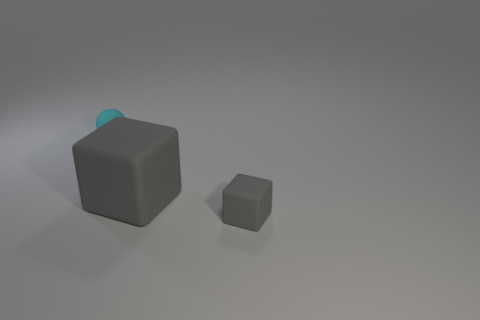What is the color of the block that is made of the same material as the large thing?
Your response must be concise. Gray. Are there fewer big brown matte objects than rubber things?
Give a very brief answer. Yes. There is a gray matte thing that is behind the tiny gray block; is it the same shape as the gray matte thing that is in front of the large gray object?
Offer a terse response. Yes. How many things are cyan matte objects or gray shiny cylinders?
Provide a short and direct response. 1. The rubber thing that is the same size as the cyan ball is what color?
Provide a short and direct response. Gray. What number of large gray matte blocks are on the left side of the gray block to the right of the big matte cube?
Make the answer very short. 1. How many things are both to the left of the tiny gray matte object and in front of the cyan rubber ball?
Offer a very short reply. 1. What number of things are small matte objects that are in front of the cyan sphere or tiny objects that are in front of the cyan object?
Offer a very short reply. 1. How many other things are there of the same size as the ball?
Offer a very short reply. 1. What is the shape of the tiny rubber object that is to the left of the gray object that is behind the tiny gray object?
Ensure brevity in your answer.  Sphere. 